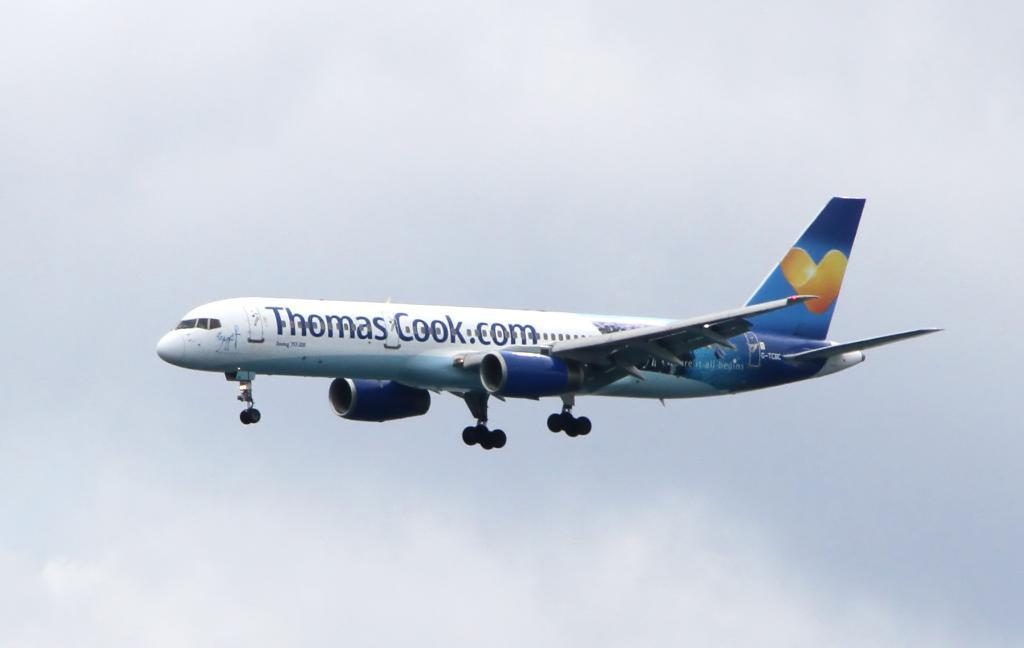<image>
Write a terse but informative summary of the picture. An airplane is in flight that has the name Thomas Cook on it. 